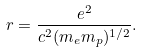<formula> <loc_0><loc_0><loc_500><loc_500>r = \frac { e ^ { 2 } } { c ^ { 2 } ( m _ { e } m _ { p } ) ^ { 1 / 2 } } .</formula> 